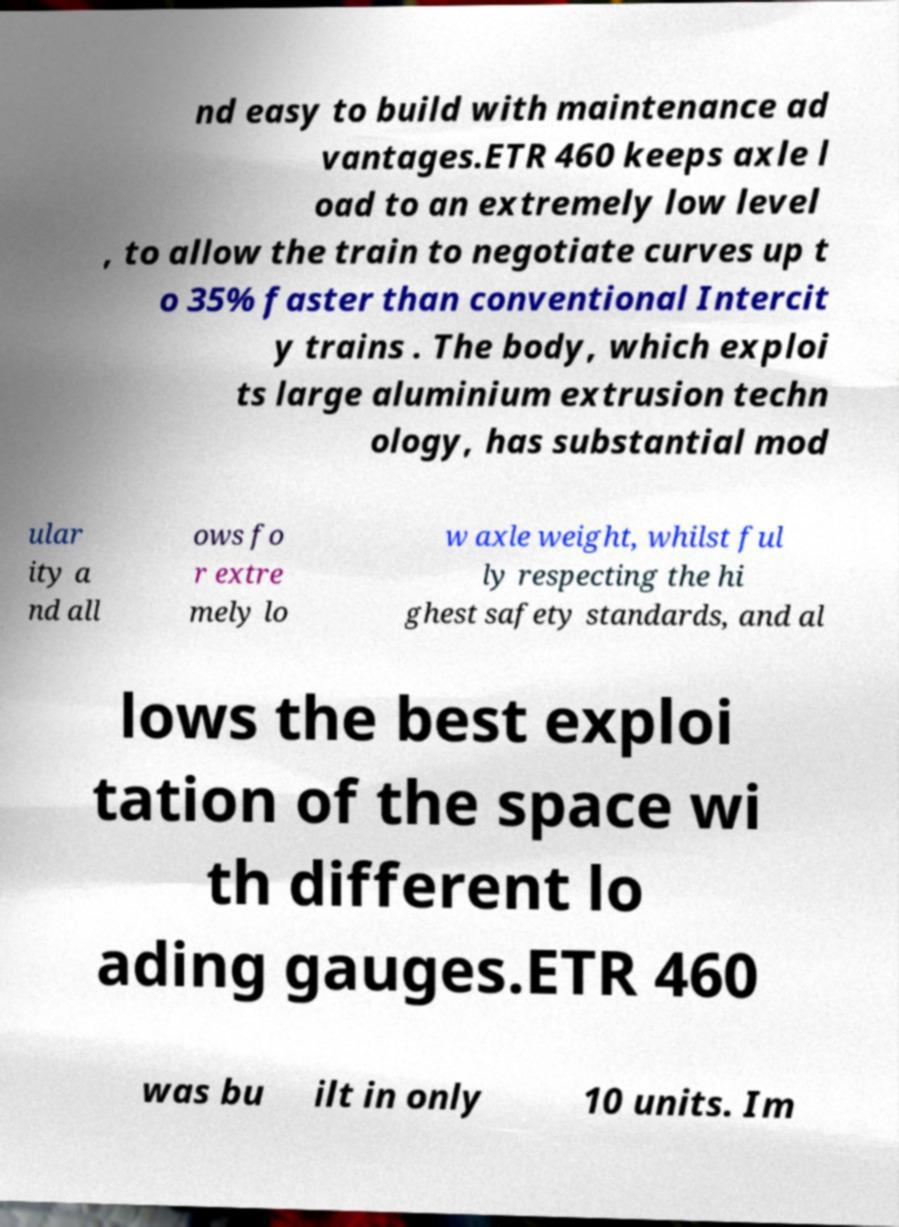Can you accurately transcribe the text from the provided image for me? nd easy to build with maintenance ad vantages.ETR 460 keeps axle l oad to an extremely low level , to allow the train to negotiate curves up t o 35% faster than conventional Intercit y trains . The body, which exploi ts large aluminium extrusion techn ology, has substantial mod ular ity a nd all ows fo r extre mely lo w axle weight, whilst ful ly respecting the hi ghest safety standards, and al lows the best exploi tation of the space wi th different lo ading gauges.ETR 460 was bu ilt in only 10 units. Im 